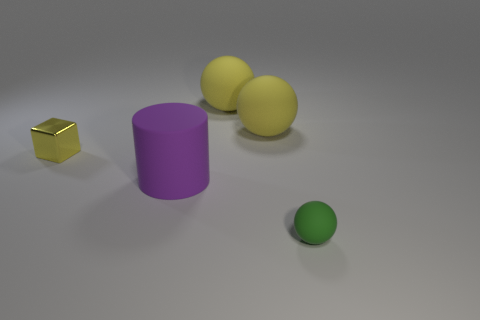What is the texture of the objects in the image? The objects exhibit two types of textures: the cube has a reflective surface suggesting a smooth and polished texture, while the cylinder and spheres have a matte finish, indicative of a non-reflective and likely rougher texture. Which object stands out the most in this image and why? The small reflective gold cube stands out due to its distinct shiny texture and the contrasting gold color, which differs from the other objects' matte finish and more subdued colors. 